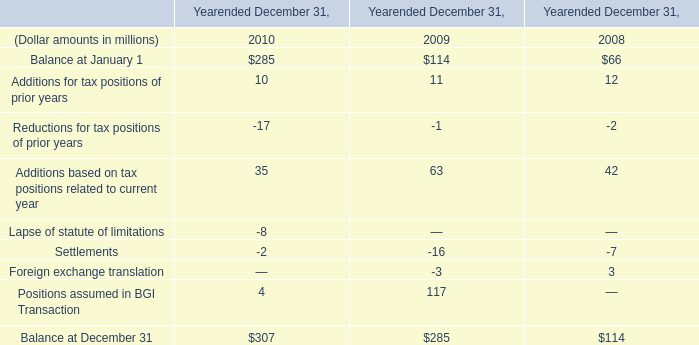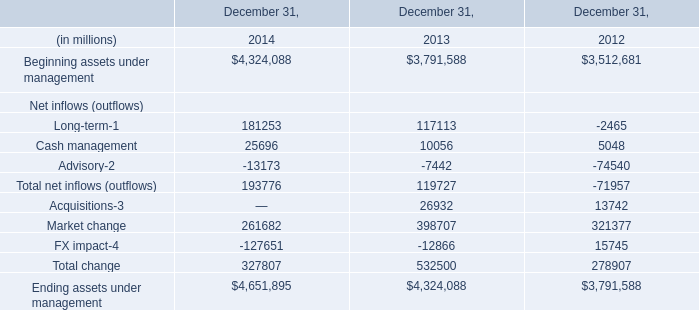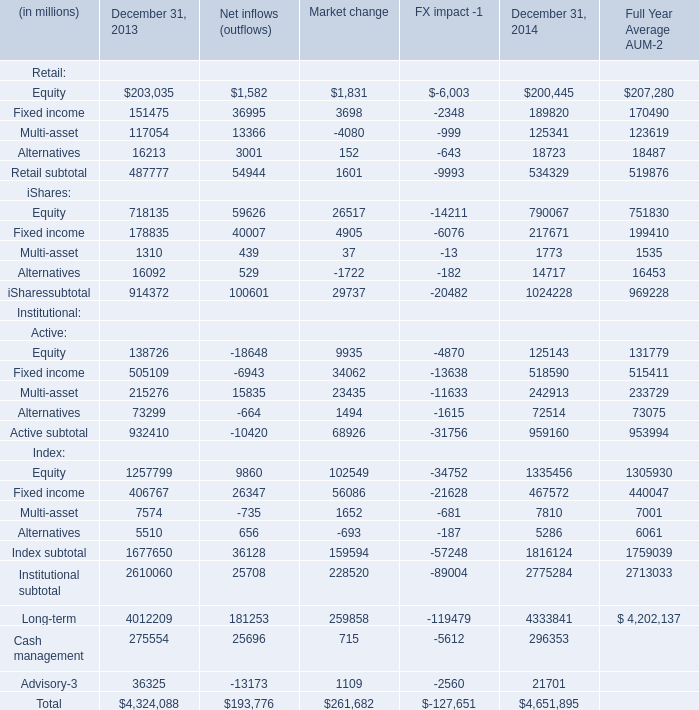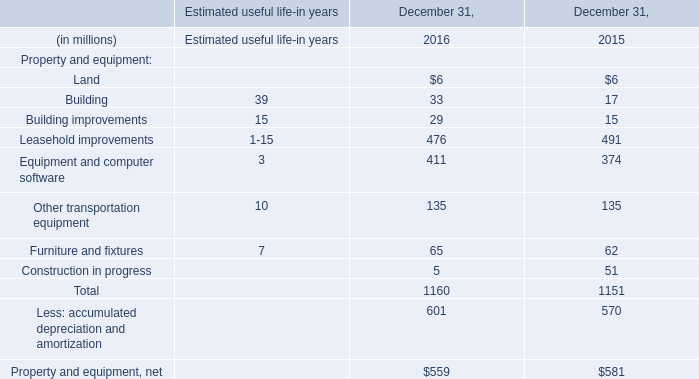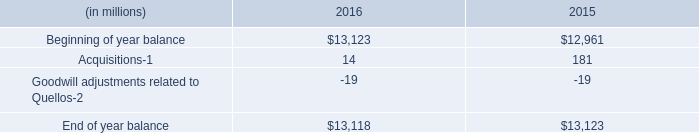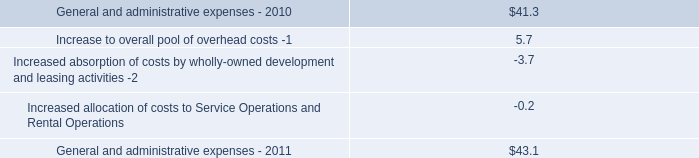What's the sum of retail without those Equity smaller than 160000, in 2013? (in million) 
Computations: ((151475 + 117054) + 16213)
Answer: 284742.0. 